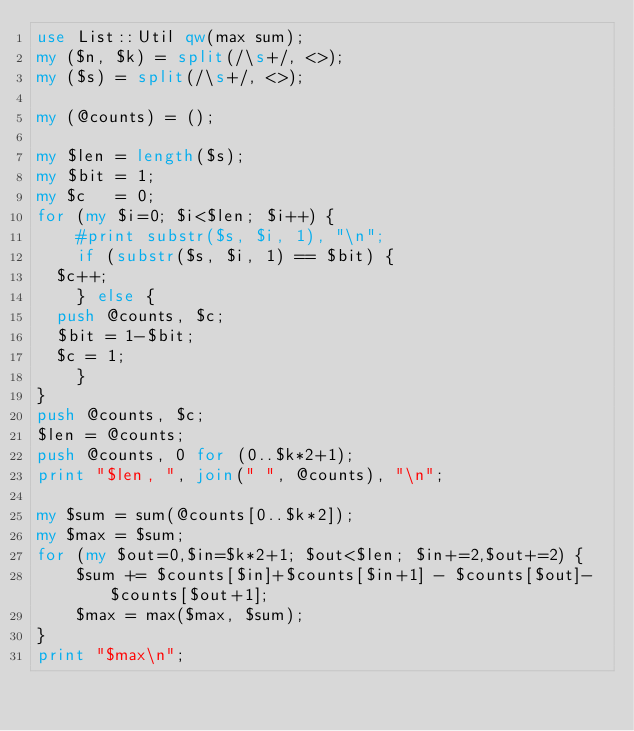Convert code to text. <code><loc_0><loc_0><loc_500><loc_500><_Perl_>use List::Util qw(max sum);
my ($n, $k) = split(/\s+/, <>);
my ($s) = split(/\s+/, <>);

my (@counts) = ();

my $len = length($s);
my $bit = 1;
my $c   = 0;
for (my $i=0; $i<$len; $i++) {
    #print substr($s, $i, 1), "\n";
    if (substr($s, $i, 1) == $bit) {
	$c++;
    } else {
	push @counts, $c;
	$bit = 1-$bit;
	$c = 1;
    }
}
push @counts, $c;
$len = @counts;
push @counts, 0 for (0..$k*2+1);
print "$len, ", join(" ", @counts), "\n";

my $sum = sum(@counts[0..$k*2]);
my $max = $sum;
for (my $out=0,$in=$k*2+1; $out<$len; $in+=2,$out+=2) {
    $sum += $counts[$in]+$counts[$in+1] - $counts[$out]-$counts[$out+1];
    $max = max($max, $sum);
}
print "$max\n";
</code> 